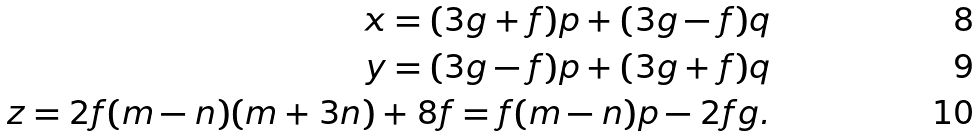<formula> <loc_0><loc_0><loc_500><loc_500>x = ( 3 g + f ) p + ( 3 g - f ) q \\ y = ( 3 g - f ) p + ( 3 g + f ) q \\ z = 2 f ( m - n ) ( m + 3 n ) + 8 f = f ( m - n ) p - 2 f g .</formula> 